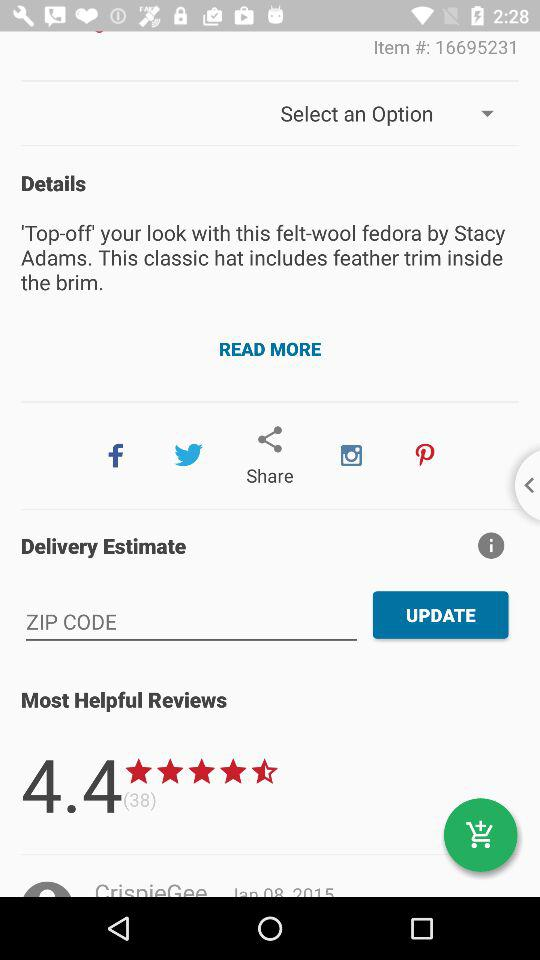What is the number of people who rated the item? The item is rated by 38 people. 